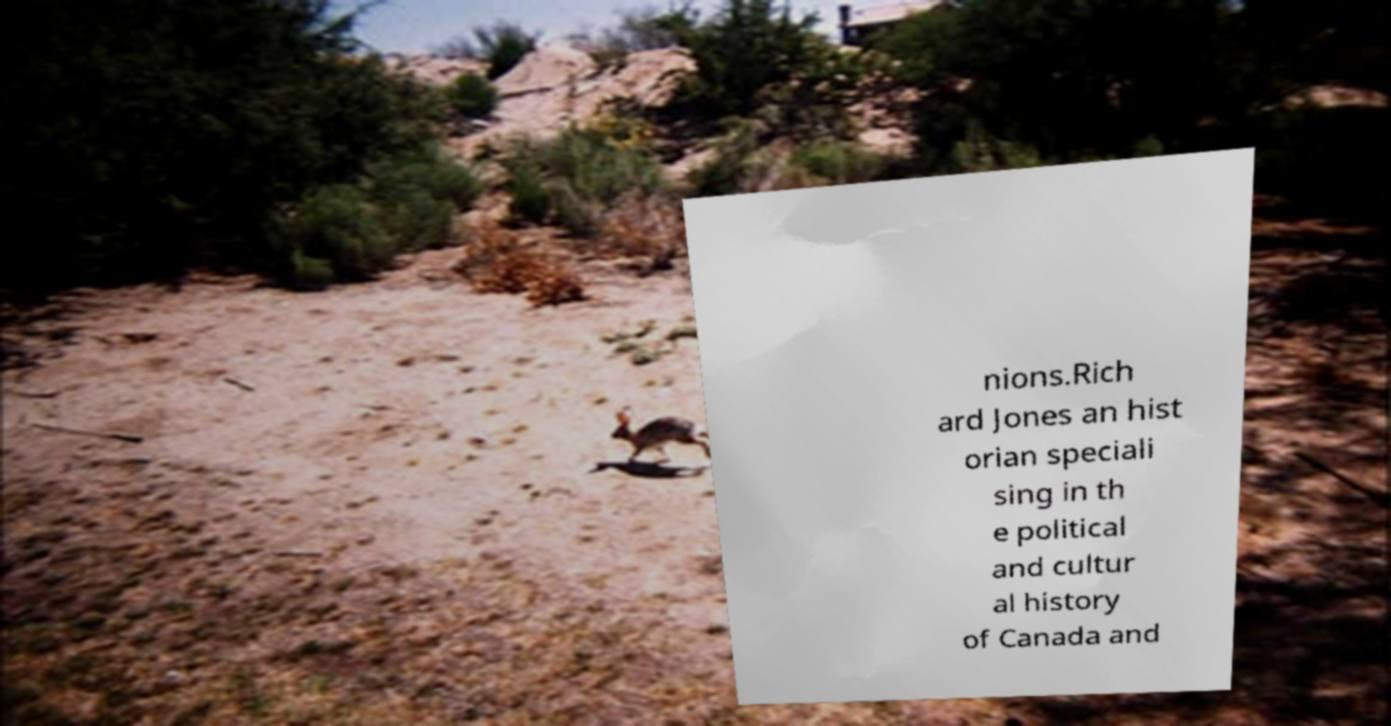Could you assist in decoding the text presented in this image and type it out clearly? nions.Rich ard Jones an hist orian speciali sing in th e political and cultur al history of Canada and 